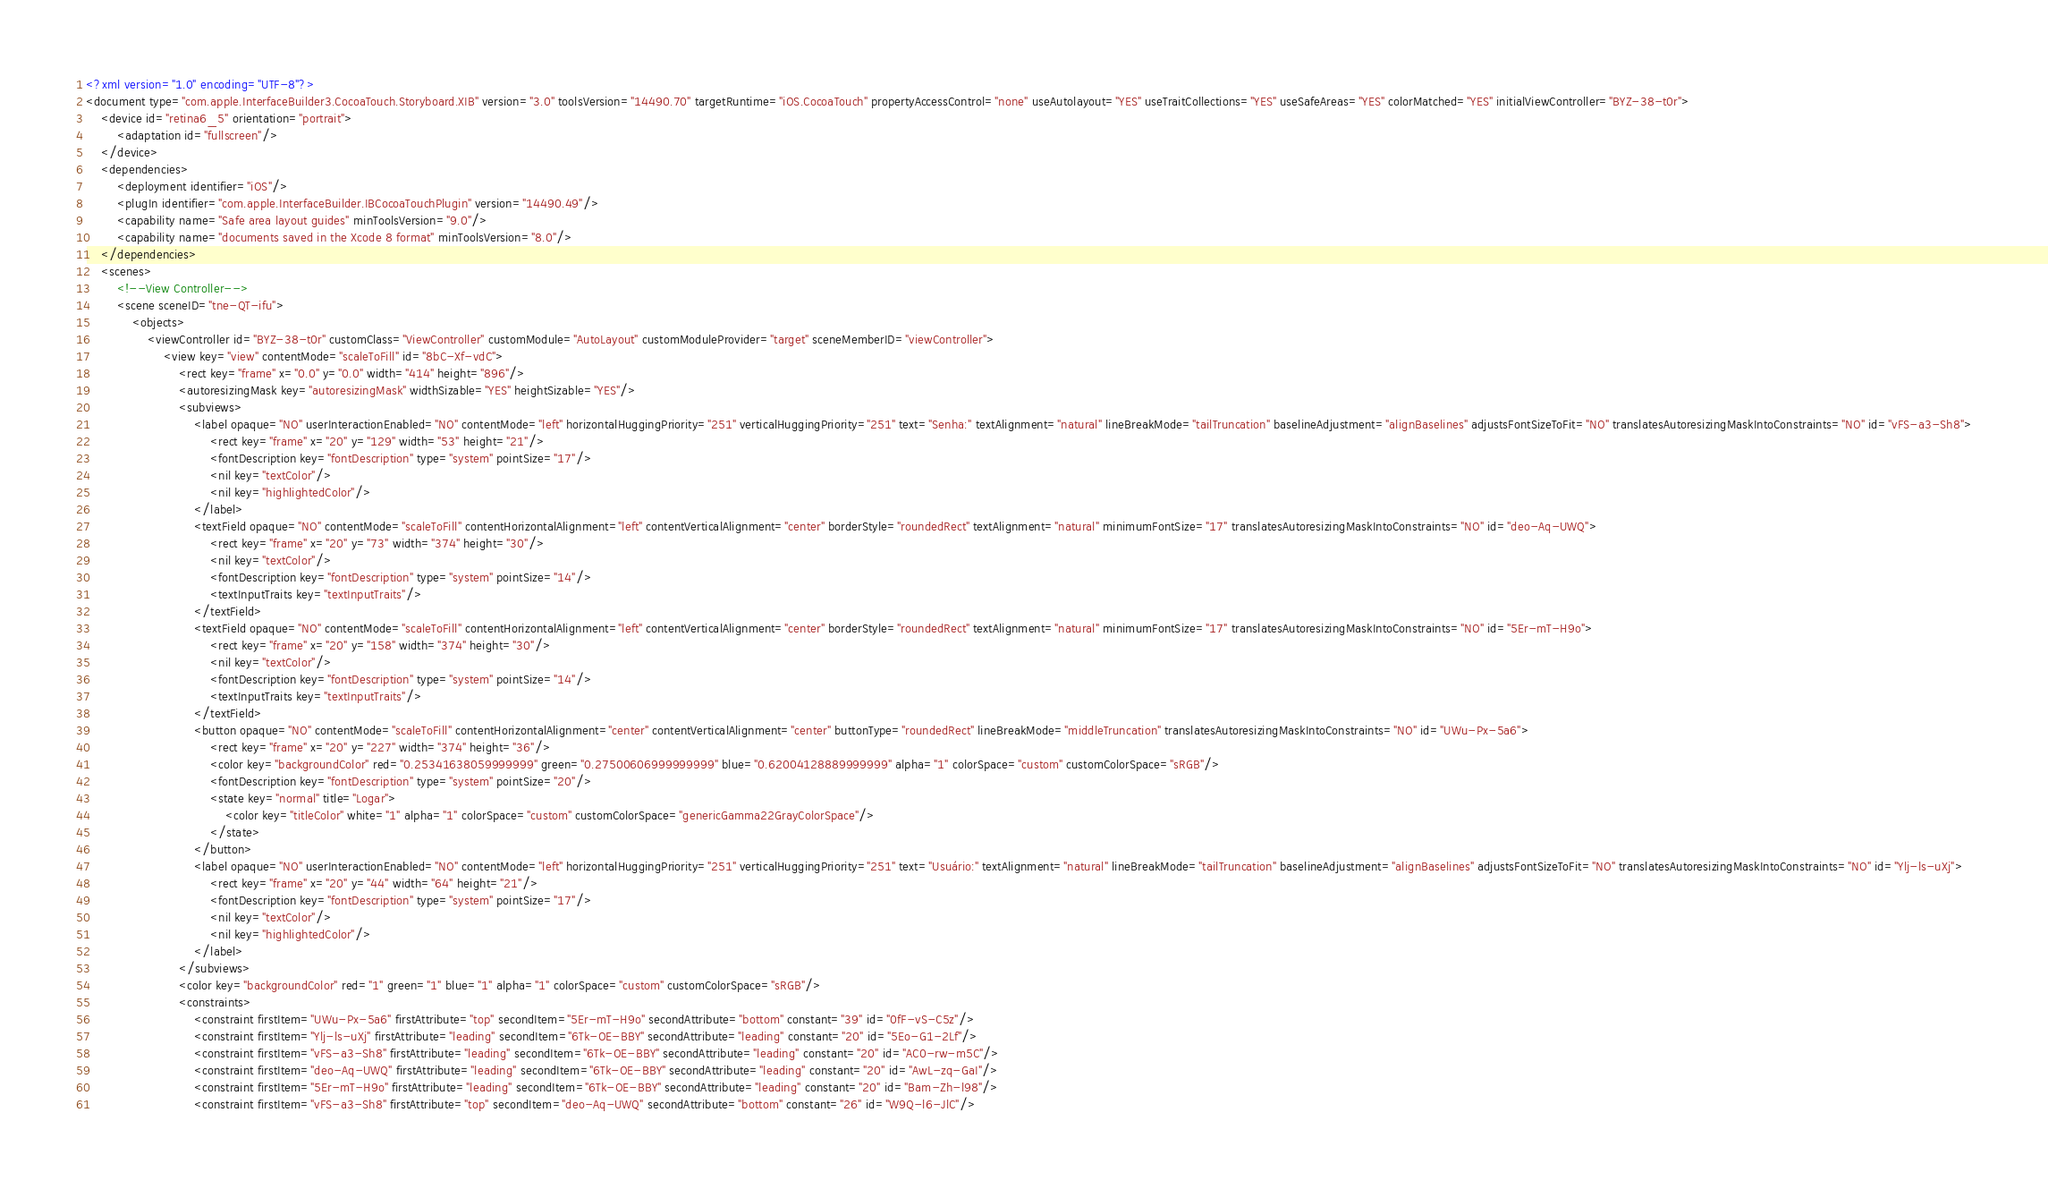Convert code to text. <code><loc_0><loc_0><loc_500><loc_500><_XML_><?xml version="1.0" encoding="UTF-8"?>
<document type="com.apple.InterfaceBuilder3.CocoaTouch.Storyboard.XIB" version="3.0" toolsVersion="14490.70" targetRuntime="iOS.CocoaTouch" propertyAccessControl="none" useAutolayout="YES" useTraitCollections="YES" useSafeAreas="YES" colorMatched="YES" initialViewController="BYZ-38-t0r">
    <device id="retina6_5" orientation="portrait">
        <adaptation id="fullscreen"/>
    </device>
    <dependencies>
        <deployment identifier="iOS"/>
        <plugIn identifier="com.apple.InterfaceBuilder.IBCocoaTouchPlugin" version="14490.49"/>
        <capability name="Safe area layout guides" minToolsVersion="9.0"/>
        <capability name="documents saved in the Xcode 8 format" minToolsVersion="8.0"/>
    </dependencies>
    <scenes>
        <!--View Controller-->
        <scene sceneID="tne-QT-ifu">
            <objects>
                <viewController id="BYZ-38-t0r" customClass="ViewController" customModule="AutoLayout" customModuleProvider="target" sceneMemberID="viewController">
                    <view key="view" contentMode="scaleToFill" id="8bC-Xf-vdC">
                        <rect key="frame" x="0.0" y="0.0" width="414" height="896"/>
                        <autoresizingMask key="autoresizingMask" widthSizable="YES" heightSizable="YES"/>
                        <subviews>
                            <label opaque="NO" userInteractionEnabled="NO" contentMode="left" horizontalHuggingPriority="251" verticalHuggingPriority="251" text="Senha:" textAlignment="natural" lineBreakMode="tailTruncation" baselineAdjustment="alignBaselines" adjustsFontSizeToFit="NO" translatesAutoresizingMaskIntoConstraints="NO" id="vFS-a3-Sh8">
                                <rect key="frame" x="20" y="129" width="53" height="21"/>
                                <fontDescription key="fontDescription" type="system" pointSize="17"/>
                                <nil key="textColor"/>
                                <nil key="highlightedColor"/>
                            </label>
                            <textField opaque="NO" contentMode="scaleToFill" contentHorizontalAlignment="left" contentVerticalAlignment="center" borderStyle="roundedRect" textAlignment="natural" minimumFontSize="17" translatesAutoresizingMaskIntoConstraints="NO" id="deo-Aq-UWQ">
                                <rect key="frame" x="20" y="73" width="374" height="30"/>
                                <nil key="textColor"/>
                                <fontDescription key="fontDescription" type="system" pointSize="14"/>
                                <textInputTraits key="textInputTraits"/>
                            </textField>
                            <textField opaque="NO" contentMode="scaleToFill" contentHorizontalAlignment="left" contentVerticalAlignment="center" borderStyle="roundedRect" textAlignment="natural" minimumFontSize="17" translatesAutoresizingMaskIntoConstraints="NO" id="5Er-mT-H9o">
                                <rect key="frame" x="20" y="158" width="374" height="30"/>
                                <nil key="textColor"/>
                                <fontDescription key="fontDescription" type="system" pointSize="14"/>
                                <textInputTraits key="textInputTraits"/>
                            </textField>
                            <button opaque="NO" contentMode="scaleToFill" contentHorizontalAlignment="center" contentVerticalAlignment="center" buttonType="roundedRect" lineBreakMode="middleTruncation" translatesAutoresizingMaskIntoConstraints="NO" id="UWu-Px-5a6">
                                <rect key="frame" x="20" y="227" width="374" height="36"/>
                                <color key="backgroundColor" red="0.25341638059999999" green="0.27500606999999999" blue="0.62004128889999999" alpha="1" colorSpace="custom" customColorSpace="sRGB"/>
                                <fontDescription key="fontDescription" type="system" pointSize="20"/>
                                <state key="normal" title="Logar">
                                    <color key="titleColor" white="1" alpha="1" colorSpace="custom" customColorSpace="genericGamma22GrayColorSpace"/>
                                </state>
                            </button>
                            <label opaque="NO" userInteractionEnabled="NO" contentMode="left" horizontalHuggingPriority="251" verticalHuggingPriority="251" text="Usuário:" textAlignment="natural" lineBreakMode="tailTruncation" baselineAdjustment="alignBaselines" adjustsFontSizeToFit="NO" translatesAutoresizingMaskIntoConstraints="NO" id="Ylj-ls-uXj">
                                <rect key="frame" x="20" y="44" width="64" height="21"/>
                                <fontDescription key="fontDescription" type="system" pointSize="17"/>
                                <nil key="textColor"/>
                                <nil key="highlightedColor"/>
                            </label>
                        </subviews>
                        <color key="backgroundColor" red="1" green="1" blue="1" alpha="1" colorSpace="custom" customColorSpace="sRGB"/>
                        <constraints>
                            <constraint firstItem="UWu-Px-5a6" firstAttribute="top" secondItem="5Er-mT-H9o" secondAttribute="bottom" constant="39" id="0fF-vS-C5z"/>
                            <constraint firstItem="Ylj-ls-uXj" firstAttribute="leading" secondItem="6Tk-OE-BBY" secondAttribute="leading" constant="20" id="5Eo-G1-2Lf"/>
                            <constraint firstItem="vFS-a3-Sh8" firstAttribute="leading" secondItem="6Tk-OE-BBY" secondAttribute="leading" constant="20" id="AC0-rw-m5C"/>
                            <constraint firstItem="deo-Aq-UWQ" firstAttribute="leading" secondItem="6Tk-OE-BBY" secondAttribute="leading" constant="20" id="AwL-zq-GaI"/>
                            <constraint firstItem="5Er-mT-H9o" firstAttribute="leading" secondItem="6Tk-OE-BBY" secondAttribute="leading" constant="20" id="Bam-Zh-l98"/>
                            <constraint firstItem="vFS-a3-Sh8" firstAttribute="top" secondItem="deo-Aq-UWQ" secondAttribute="bottom" constant="26" id="W9Q-l6-JlC"/></code> 